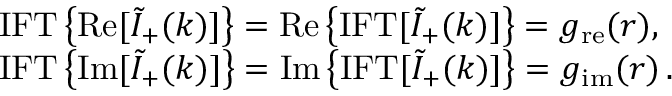<formula> <loc_0><loc_0><loc_500><loc_500>\begin{array} { r l } & { { I F T } \left \{ R e [ \tilde { I } _ { + } ( k ) ] \right \} = R e \left \{ { I F T } [ \tilde { I } _ { + } ( k ) ] \right \} = g _ { r e } ( r ) , } \\ & { { I F T } \left \{ I m [ \tilde { I } _ { + } ( k ) ] \right \} = I m \left \{ { I F T } [ \tilde { I } _ { + } ( k ) ] \right \} = g _ { i m } ( r ) \, . } \end{array}</formula> 